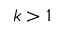Convert formula to latex. <formula><loc_0><loc_0><loc_500><loc_500>k > 1</formula> 